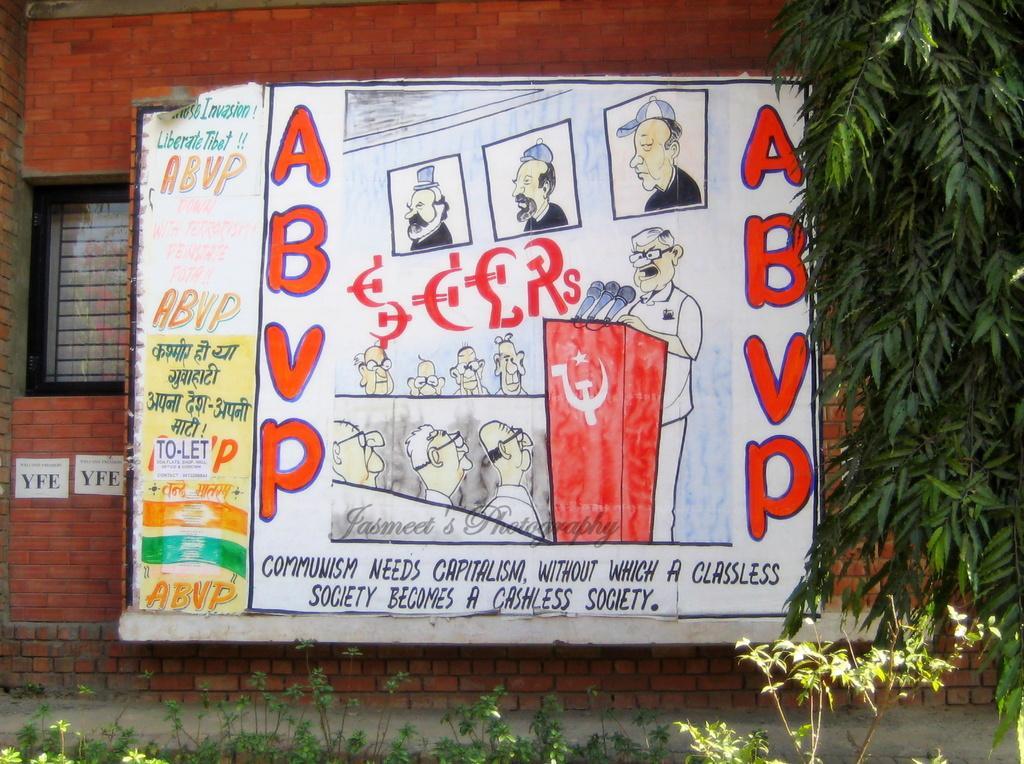Could you give a brief overview of what you see in this image? In the image in the center there is a poster. On the poster, we can see few people and something written on it. In the background there is a wall, window, trees, plants etc. 